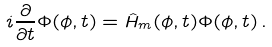<formula> <loc_0><loc_0><loc_500><loc_500>i \frac { \partial } { \partial t } \Phi ( \phi , t ) = \hat { H } _ { m } ( \phi , t ) \Phi ( \phi , t ) \, .</formula> 